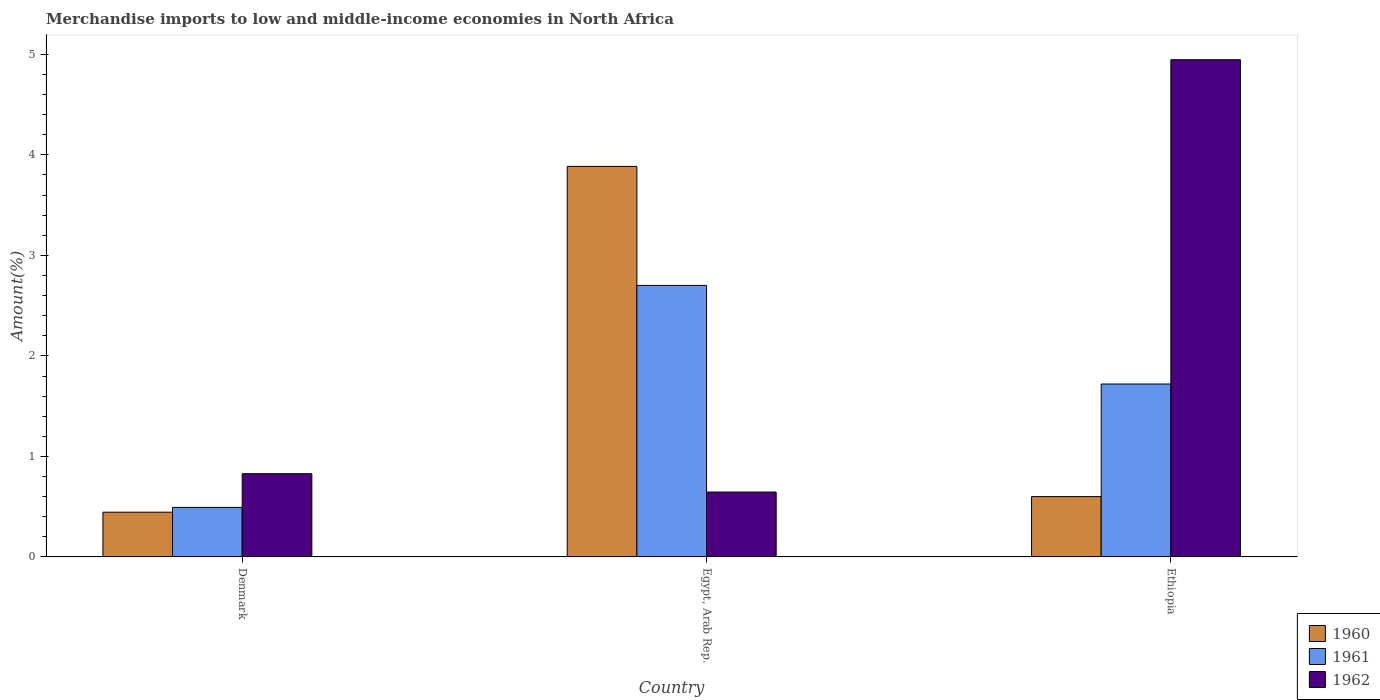How many groups of bars are there?
Give a very brief answer. 3. Are the number of bars per tick equal to the number of legend labels?
Your answer should be compact. Yes. What is the percentage of amount earned from merchandise imports in 1962 in Denmark?
Ensure brevity in your answer.  0.83. Across all countries, what is the maximum percentage of amount earned from merchandise imports in 1962?
Your response must be concise. 4.95. Across all countries, what is the minimum percentage of amount earned from merchandise imports in 1962?
Your answer should be very brief. 0.65. In which country was the percentage of amount earned from merchandise imports in 1960 maximum?
Keep it short and to the point. Egypt, Arab Rep. In which country was the percentage of amount earned from merchandise imports in 1962 minimum?
Your answer should be very brief. Egypt, Arab Rep. What is the total percentage of amount earned from merchandise imports in 1961 in the graph?
Offer a very short reply. 4.91. What is the difference between the percentage of amount earned from merchandise imports in 1961 in Denmark and that in Egypt, Arab Rep.?
Your response must be concise. -2.21. What is the difference between the percentage of amount earned from merchandise imports in 1962 in Egypt, Arab Rep. and the percentage of amount earned from merchandise imports in 1960 in Denmark?
Give a very brief answer. 0.2. What is the average percentage of amount earned from merchandise imports in 1962 per country?
Offer a very short reply. 2.14. What is the difference between the percentage of amount earned from merchandise imports of/in 1960 and percentage of amount earned from merchandise imports of/in 1962 in Egypt, Arab Rep.?
Provide a short and direct response. 3.24. In how many countries, is the percentage of amount earned from merchandise imports in 1962 greater than 1.2 %?
Ensure brevity in your answer.  1. What is the ratio of the percentage of amount earned from merchandise imports in 1962 in Denmark to that in Egypt, Arab Rep.?
Offer a very short reply. 1.28. Is the percentage of amount earned from merchandise imports in 1961 in Denmark less than that in Ethiopia?
Offer a terse response. Yes. What is the difference between the highest and the second highest percentage of amount earned from merchandise imports in 1961?
Your answer should be very brief. -1.23. What is the difference between the highest and the lowest percentage of amount earned from merchandise imports in 1961?
Give a very brief answer. 2.21. In how many countries, is the percentage of amount earned from merchandise imports in 1962 greater than the average percentage of amount earned from merchandise imports in 1962 taken over all countries?
Your response must be concise. 1. What does the 3rd bar from the left in Egypt, Arab Rep. represents?
Your response must be concise. 1962. Is it the case that in every country, the sum of the percentage of amount earned from merchandise imports in 1960 and percentage of amount earned from merchandise imports in 1962 is greater than the percentage of amount earned from merchandise imports in 1961?
Ensure brevity in your answer.  Yes. How many bars are there?
Ensure brevity in your answer.  9. Where does the legend appear in the graph?
Your answer should be very brief. Bottom right. How many legend labels are there?
Keep it short and to the point. 3. What is the title of the graph?
Give a very brief answer. Merchandise imports to low and middle-income economies in North Africa. What is the label or title of the X-axis?
Your answer should be very brief. Country. What is the label or title of the Y-axis?
Offer a terse response. Amount(%). What is the Amount(%) of 1960 in Denmark?
Your answer should be compact. 0.45. What is the Amount(%) of 1961 in Denmark?
Provide a succinct answer. 0.49. What is the Amount(%) in 1962 in Denmark?
Give a very brief answer. 0.83. What is the Amount(%) in 1960 in Egypt, Arab Rep.?
Provide a succinct answer. 3.89. What is the Amount(%) of 1961 in Egypt, Arab Rep.?
Provide a succinct answer. 2.7. What is the Amount(%) of 1962 in Egypt, Arab Rep.?
Your response must be concise. 0.65. What is the Amount(%) in 1960 in Ethiopia?
Ensure brevity in your answer.  0.6. What is the Amount(%) of 1961 in Ethiopia?
Your answer should be compact. 1.72. What is the Amount(%) in 1962 in Ethiopia?
Provide a succinct answer. 4.95. Across all countries, what is the maximum Amount(%) of 1960?
Provide a succinct answer. 3.89. Across all countries, what is the maximum Amount(%) of 1961?
Your response must be concise. 2.7. Across all countries, what is the maximum Amount(%) in 1962?
Offer a very short reply. 4.95. Across all countries, what is the minimum Amount(%) in 1960?
Provide a short and direct response. 0.45. Across all countries, what is the minimum Amount(%) of 1961?
Ensure brevity in your answer.  0.49. Across all countries, what is the minimum Amount(%) in 1962?
Provide a short and direct response. 0.65. What is the total Amount(%) of 1960 in the graph?
Offer a terse response. 4.93. What is the total Amount(%) of 1961 in the graph?
Your response must be concise. 4.91. What is the total Amount(%) in 1962 in the graph?
Make the answer very short. 6.42. What is the difference between the Amount(%) in 1960 in Denmark and that in Egypt, Arab Rep.?
Make the answer very short. -3.44. What is the difference between the Amount(%) in 1961 in Denmark and that in Egypt, Arab Rep.?
Your response must be concise. -2.21. What is the difference between the Amount(%) in 1962 in Denmark and that in Egypt, Arab Rep.?
Offer a very short reply. 0.18. What is the difference between the Amount(%) of 1960 in Denmark and that in Ethiopia?
Your response must be concise. -0.16. What is the difference between the Amount(%) in 1961 in Denmark and that in Ethiopia?
Offer a very short reply. -1.23. What is the difference between the Amount(%) in 1962 in Denmark and that in Ethiopia?
Keep it short and to the point. -4.12. What is the difference between the Amount(%) of 1960 in Egypt, Arab Rep. and that in Ethiopia?
Keep it short and to the point. 3.29. What is the difference between the Amount(%) in 1961 in Egypt, Arab Rep. and that in Ethiopia?
Ensure brevity in your answer.  0.98. What is the difference between the Amount(%) of 1962 in Egypt, Arab Rep. and that in Ethiopia?
Give a very brief answer. -4.3. What is the difference between the Amount(%) in 1960 in Denmark and the Amount(%) in 1961 in Egypt, Arab Rep.?
Ensure brevity in your answer.  -2.26. What is the difference between the Amount(%) of 1960 in Denmark and the Amount(%) of 1962 in Egypt, Arab Rep.?
Your answer should be very brief. -0.2. What is the difference between the Amount(%) of 1961 in Denmark and the Amount(%) of 1962 in Egypt, Arab Rep.?
Keep it short and to the point. -0.15. What is the difference between the Amount(%) in 1960 in Denmark and the Amount(%) in 1961 in Ethiopia?
Provide a succinct answer. -1.28. What is the difference between the Amount(%) of 1960 in Denmark and the Amount(%) of 1962 in Ethiopia?
Your answer should be compact. -4.5. What is the difference between the Amount(%) in 1961 in Denmark and the Amount(%) in 1962 in Ethiopia?
Offer a terse response. -4.45. What is the difference between the Amount(%) in 1960 in Egypt, Arab Rep. and the Amount(%) in 1961 in Ethiopia?
Make the answer very short. 2.17. What is the difference between the Amount(%) of 1960 in Egypt, Arab Rep. and the Amount(%) of 1962 in Ethiopia?
Your answer should be compact. -1.06. What is the difference between the Amount(%) in 1961 in Egypt, Arab Rep. and the Amount(%) in 1962 in Ethiopia?
Your response must be concise. -2.25. What is the average Amount(%) in 1960 per country?
Keep it short and to the point. 1.64. What is the average Amount(%) in 1961 per country?
Your answer should be compact. 1.64. What is the average Amount(%) of 1962 per country?
Provide a succinct answer. 2.14. What is the difference between the Amount(%) of 1960 and Amount(%) of 1961 in Denmark?
Your response must be concise. -0.05. What is the difference between the Amount(%) of 1960 and Amount(%) of 1962 in Denmark?
Offer a terse response. -0.38. What is the difference between the Amount(%) of 1961 and Amount(%) of 1962 in Denmark?
Your answer should be compact. -0.34. What is the difference between the Amount(%) of 1960 and Amount(%) of 1961 in Egypt, Arab Rep.?
Make the answer very short. 1.18. What is the difference between the Amount(%) of 1960 and Amount(%) of 1962 in Egypt, Arab Rep.?
Provide a short and direct response. 3.24. What is the difference between the Amount(%) of 1961 and Amount(%) of 1962 in Egypt, Arab Rep.?
Your response must be concise. 2.06. What is the difference between the Amount(%) of 1960 and Amount(%) of 1961 in Ethiopia?
Give a very brief answer. -1.12. What is the difference between the Amount(%) of 1960 and Amount(%) of 1962 in Ethiopia?
Ensure brevity in your answer.  -4.35. What is the difference between the Amount(%) of 1961 and Amount(%) of 1962 in Ethiopia?
Provide a short and direct response. -3.23. What is the ratio of the Amount(%) of 1960 in Denmark to that in Egypt, Arab Rep.?
Offer a very short reply. 0.11. What is the ratio of the Amount(%) in 1961 in Denmark to that in Egypt, Arab Rep.?
Give a very brief answer. 0.18. What is the ratio of the Amount(%) in 1962 in Denmark to that in Egypt, Arab Rep.?
Ensure brevity in your answer.  1.28. What is the ratio of the Amount(%) of 1960 in Denmark to that in Ethiopia?
Offer a very short reply. 0.74. What is the ratio of the Amount(%) of 1961 in Denmark to that in Ethiopia?
Provide a short and direct response. 0.29. What is the ratio of the Amount(%) in 1962 in Denmark to that in Ethiopia?
Keep it short and to the point. 0.17. What is the ratio of the Amount(%) in 1960 in Egypt, Arab Rep. to that in Ethiopia?
Your answer should be compact. 6.47. What is the ratio of the Amount(%) of 1961 in Egypt, Arab Rep. to that in Ethiopia?
Ensure brevity in your answer.  1.57. What is the ratio of the Amount(%) of 1962 in Egypt, Arab Rep. to that in Ethiopia?
Make the answer very short. 0.13. What is the difference between the highest and the second highest Amount(%) in 1960?
Provide a short and direct response. 3.29. What is the difference between the highest and the second highest Amount(%) of 1961?
Offer a very short reply. 0.98. What is the difference between the highest and the second highest Amount(%) of 1962?
Offer a very short reply. 4.12. What is the difference between the highest and the lowest Amount(%) in 1960?
Ensure brevity in your answer.  3.44. What is the difference between the highest and the lowest Amount(%) of 1961?
Offer a very short reply. 2.21. What is the difference between the highest and the lowest Amount(%) of 1962?
Make the answer very short. 4.3. 